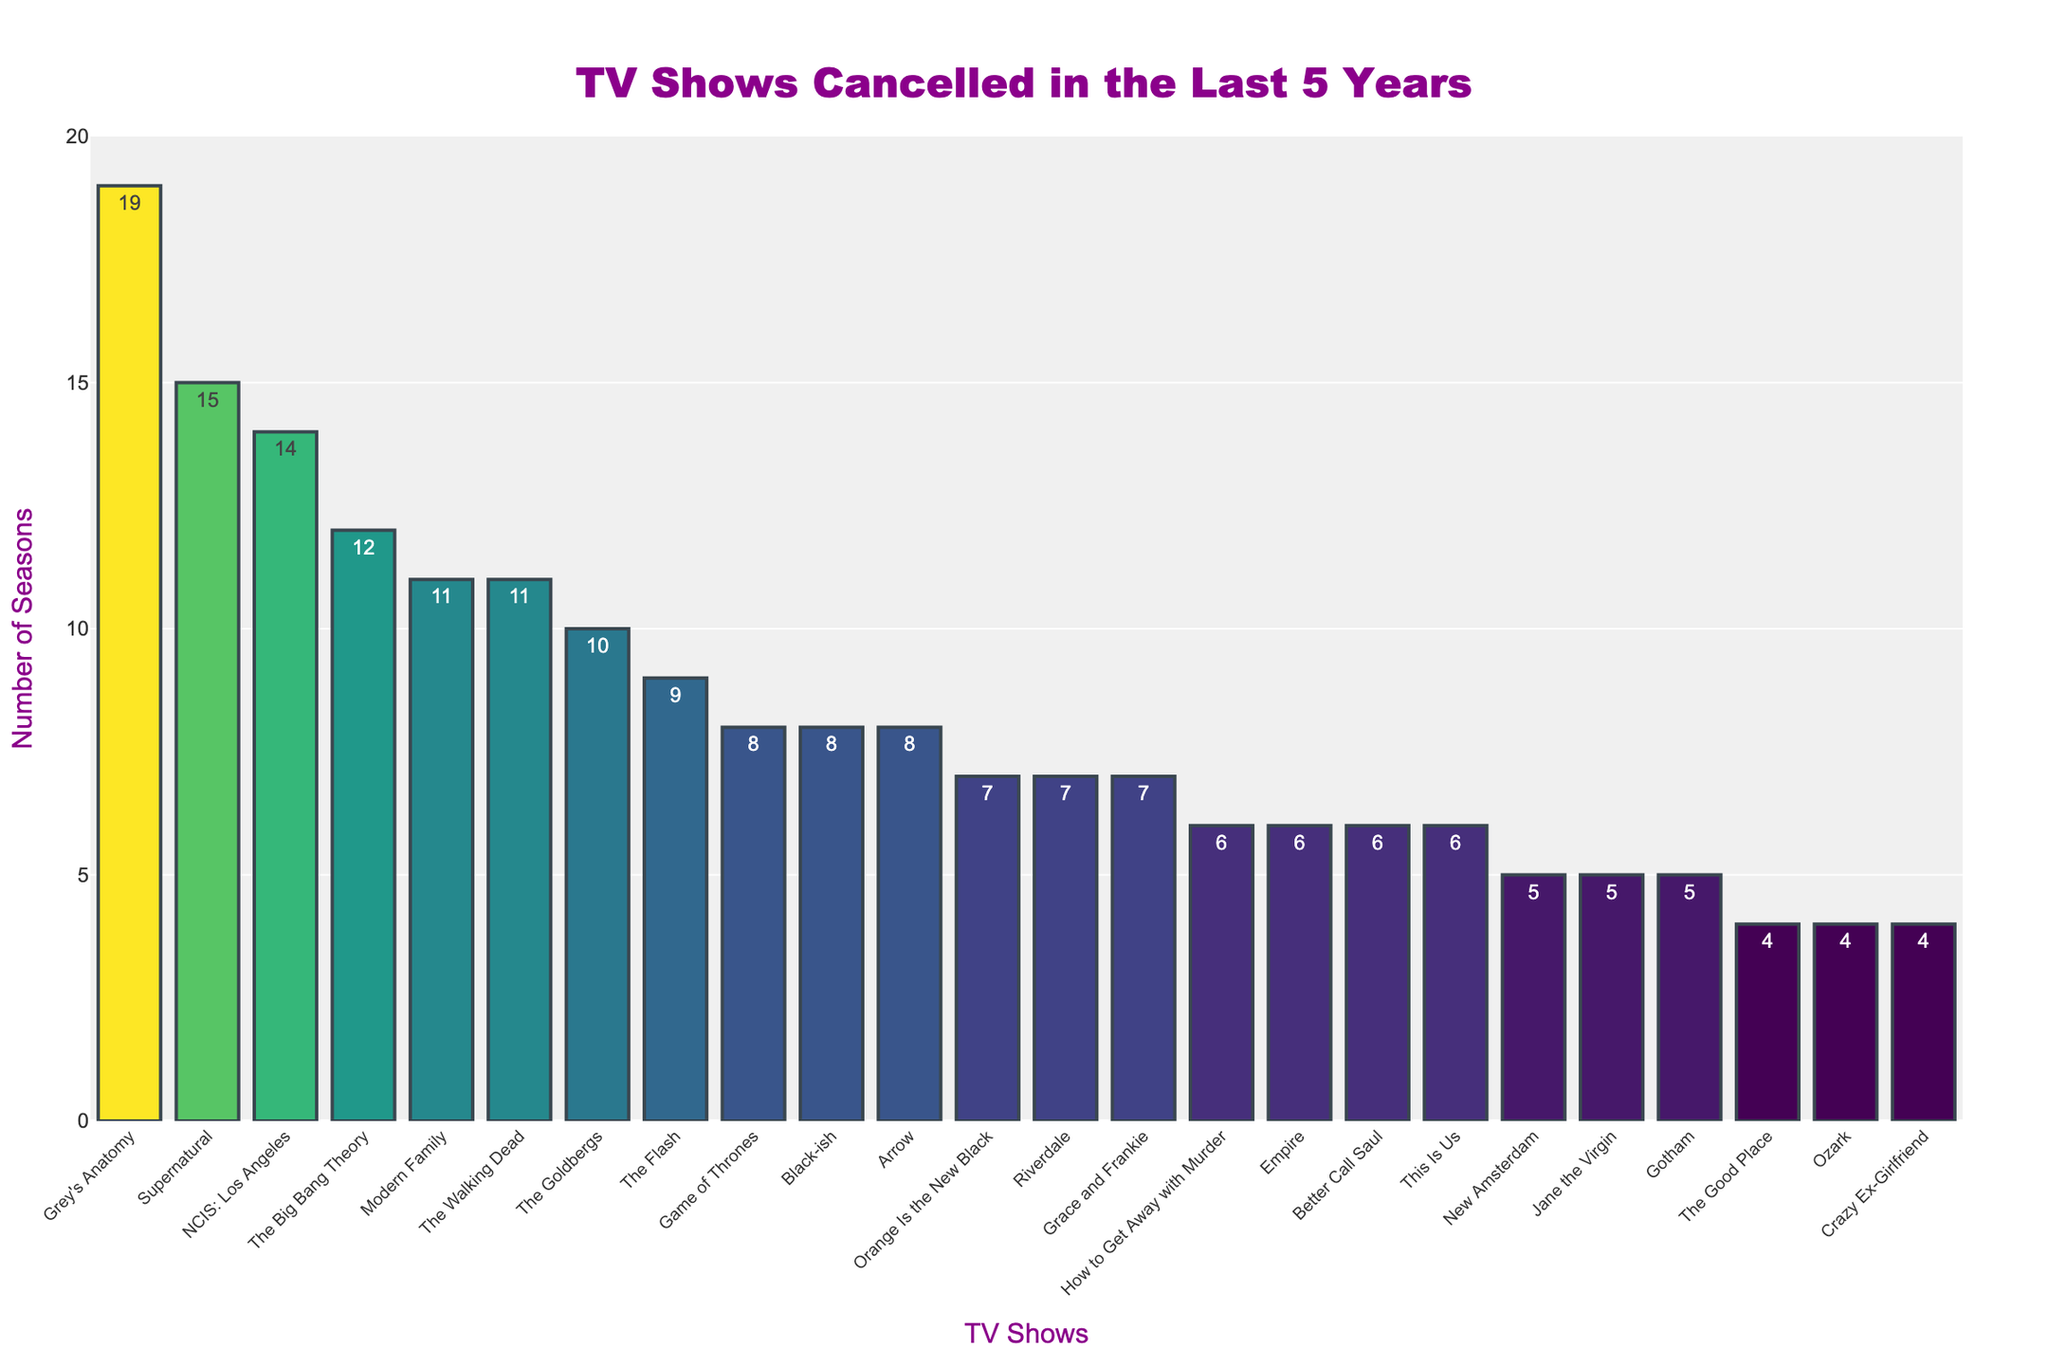Which show had the highest season count before being cancelled? The show with the highest season count before being cancelled can be identified by the tallest bar in the chart. Grey's Anatomy, with 19 seasons, has the tallest bar.
Answer: Grey's Anatomy Which network had the most shows cancelled with at least 7 seasons in the past 5 years? Identify the shows with 7 or more seasons and then count how many such shows were cancelled by each network. ABC had Modern Family (11 seasons), Grey's Anatomy (19 seasons), The Goldbergs (10 seasons), and Black-ish (8 seasons), totaling 4 shows.
Answer: ABC Which show on Netflix had the longest run before being cancelled? Look for the highest bar among the Netflix shows in the chart. Orange Is the New Black had 7 seasons, which is the highest among Netflix shows cancelled.
Answer: Orange Is the New Black How many shows with exactly 8 seasons were cancelled? Count the bars that reach the 8-season mark. The shows with exactly 8 seasons are Arrow, Game of Thrones, and Black-ish, totaling 3 shows.
Answer: 3 What is the total number of seasons for shows canceled by NBC? Sum up the seasons of all the NBC shows: New Amsterdam (5 seasons), This Is Us (6 seasons), and The Good Place (4 seasons), resulting in a total of 15 seasons.
Answer: 15 Which years saw the most cancellations of shows with 5 seasons or more? Identify the years with the highest number of shows that had 5 or more seasons. By counting, 2020 had Modern Family, Supernatural, How to Get Away with Murder, and Empire, totaling 4 shows.
Answer: 2020 Are more shows cancelled in 2020 or 2022? Count the number of shows cancelled in each of the two years. In 2020, 6 shows were cancelled, and in 2022, 6 shows were also cancelled, so they are equal.
Answer: Equal (6 each) Which show had more seasons, The Walking Dead or The Big Bang Theory? Compare the heights of the bars for The Walking Dead and The Big Bang Theory. The Big Bang Theory had 12 seasons, while The Walking Dead had 11 seasons.
Answer: The Big Bang Theory How many shows were cancelled by The CW in 2023? Identify the number of shows from The CW cancelled in 2023: Riverdale and The Flash, totaling 2 shows.
Answer: 2 Which network had the highest average number of seasons for their cancelled shows? Calculate the average number of seasons for each network's cancelled shows and compare. The CW has Riverdale (7), The Flash (9), Supernatural (15), Arrow (8), and Crazy Ex-Girlfriend (4), averaging (7+9+15+8+4)/5 = 8.6. Other networks have lower averages.
Answer: The CW 